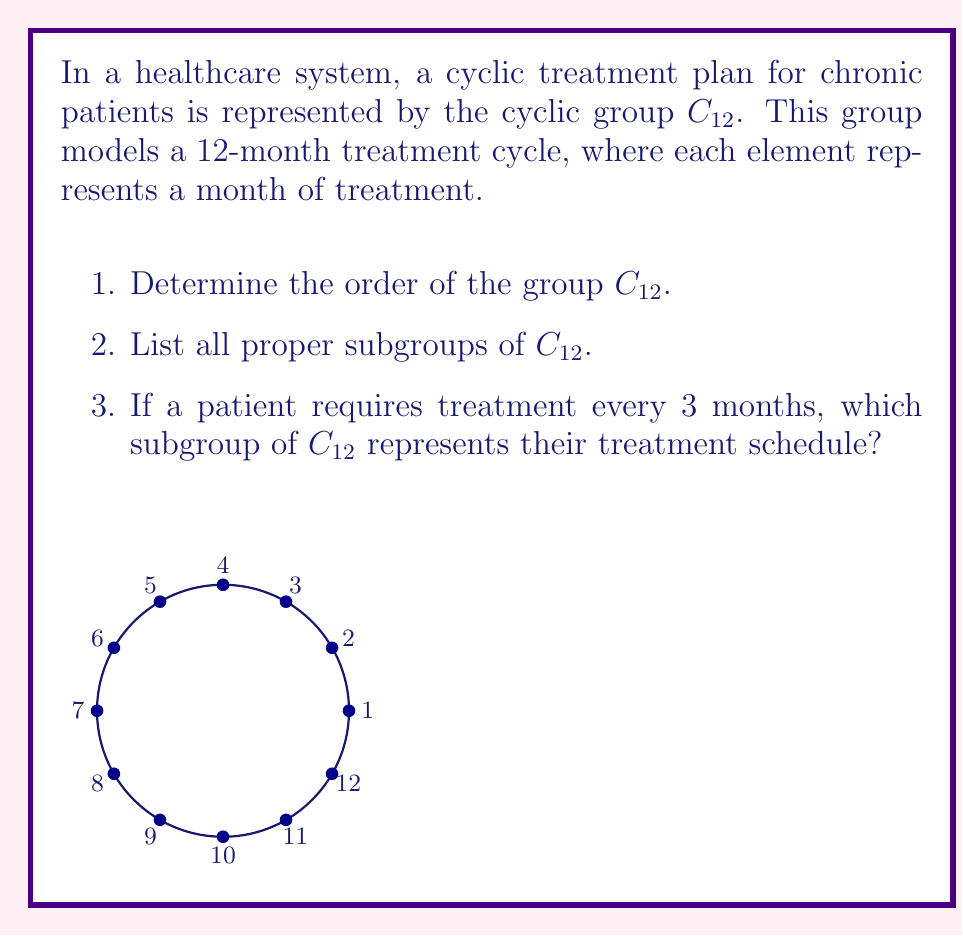Could you help me with this problem? Let's approach this step-by-step:

1. Order of $C_{12}$:
   The order of a cyclic group $C_n$ is always $n$.
   Therefore, $|C_{12}| = 12$.

2. Proper subgroups of $C_{12}$:
   The subgroups of a cyclic group $C_n$ are cyclic groups $C_d$ where $d$ is a divisor of $n$.
   The divisors of 12 are 1, 2, 3, 4, 6, and 12.
   Excluding 1 (trivial subgroup) and 12 (the whole group), the proper subgroups are:
   
   - $C_2 = \{0, 6\}$ (modulo 12)
   - $C_3 = \{0, 4, 8\}$ (modulo 12)
   - $C_4 = \{0, 3, 6, 9\}$ (modulo 12)
   - $C_6 = \{0, 2, 4, 6, 8, 10\}$ (modulo 12)

3. Patient treatment every 3 months:
   This schedule repeats every 3 months, so it forms a cycle of order 4 within the 12-month cycle.
   This corresponds to the subgroup $C_4 = \{0, 3, 6, 9\}$ (modulo 12).

This group-theoretic approach allows healthcare professionals to model and analyze various treatment cycles within a standardized annual framework, potentially improving treatment scheduling and resource allocation.
Answer: 1. $|C_{12}| = 12$
2. $C_2, C_3, C_4, C_6$
3. $C_4 = \{0, 3, 6, 9\}$ 